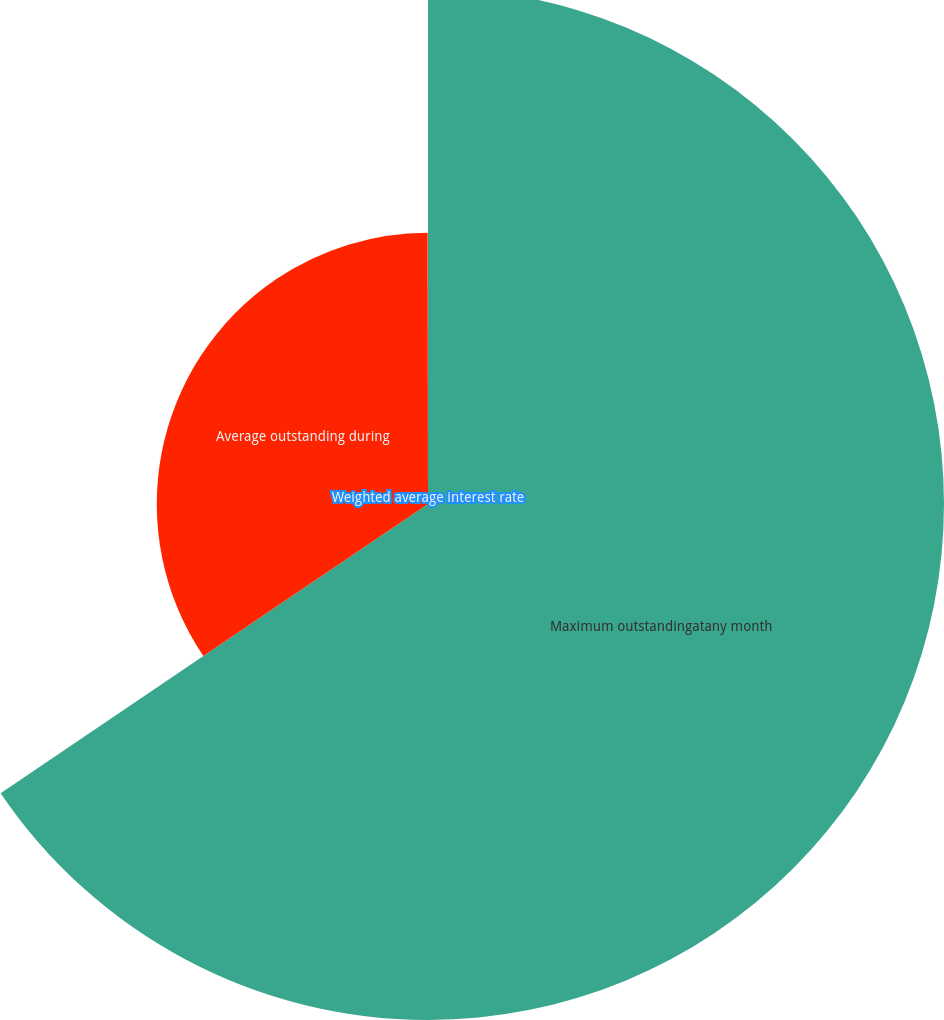<chart> <loc_0><loc_0><loc_500><loc_500><pie_chart><fcel>Maximum outstandingatany month<fcel>Average outstanding during<fcel>Weighted average interest rate<nl><fcel>65.54%<fcel>34.45%<fcel>0.02%<nl></chart> 